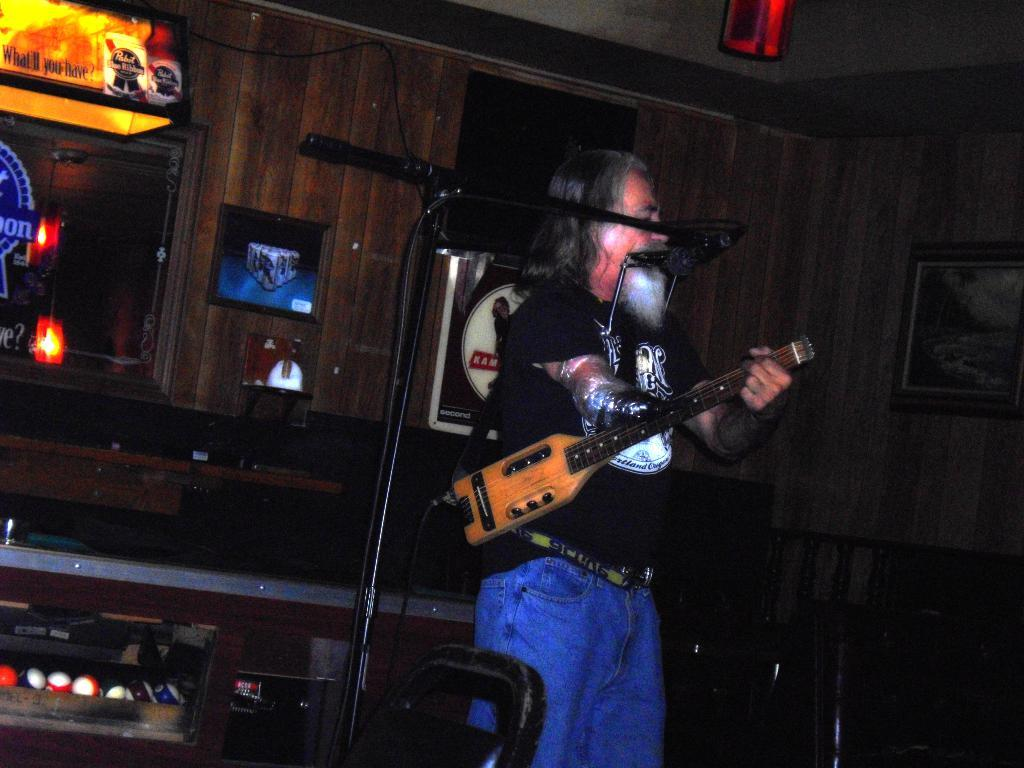<image>
Describe the image concisely. A man is playing guitar in front of a sign that says what will you have. 